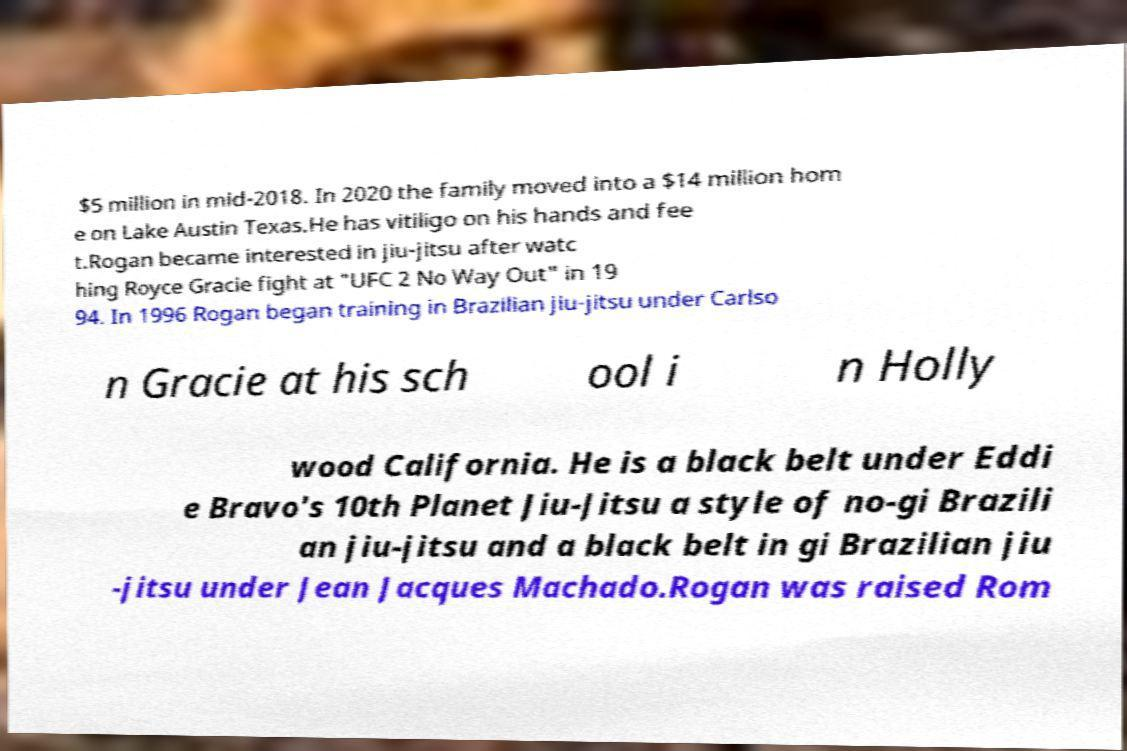Could you assist in decoding the text presented in this image and type it out clearly? $5 million in mid-2018. In 2020 the family moved into a $14 million hom e on Lake Austin Texas.He has vitiligo on his hands and fee t.Rogan became interested in jiu-jitsu after watc hing Royce Gracie fight at "UFC 2 No Way Out" in 19 94. In 1996 Rogan began training in Brazilian jiu-jitsu under Carlso n Gracie at his sch ool i n Holly wood California. He is a black belt under Eddi e Bravo's 10th Planet Jiu-Jitsu a style of no-gi Brazili an jiu-jitsu and a black belt in gi Brazilian jiu -jitsu under Jean Jacques Machado.Rogan was raised Rom 